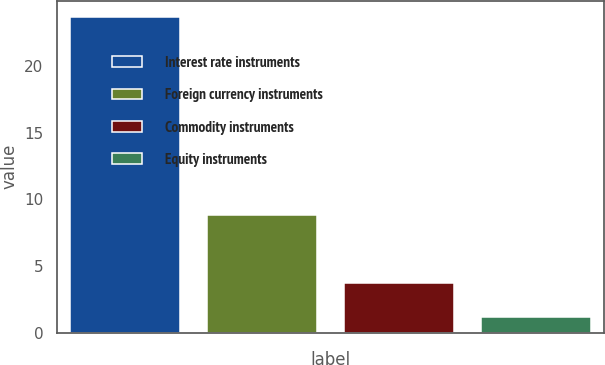<chart> <loc_0><loc_0><loc_500><loc_500><bar_chart><fcel>Interest rate instruments<fcel>Foreign currency instruments<fcel>Commodity instruments<fcel>Equity instruments<nl><fcel>23.7<fcel>8.8<fcel>3.7<fcel>1.2<nl></chart> 